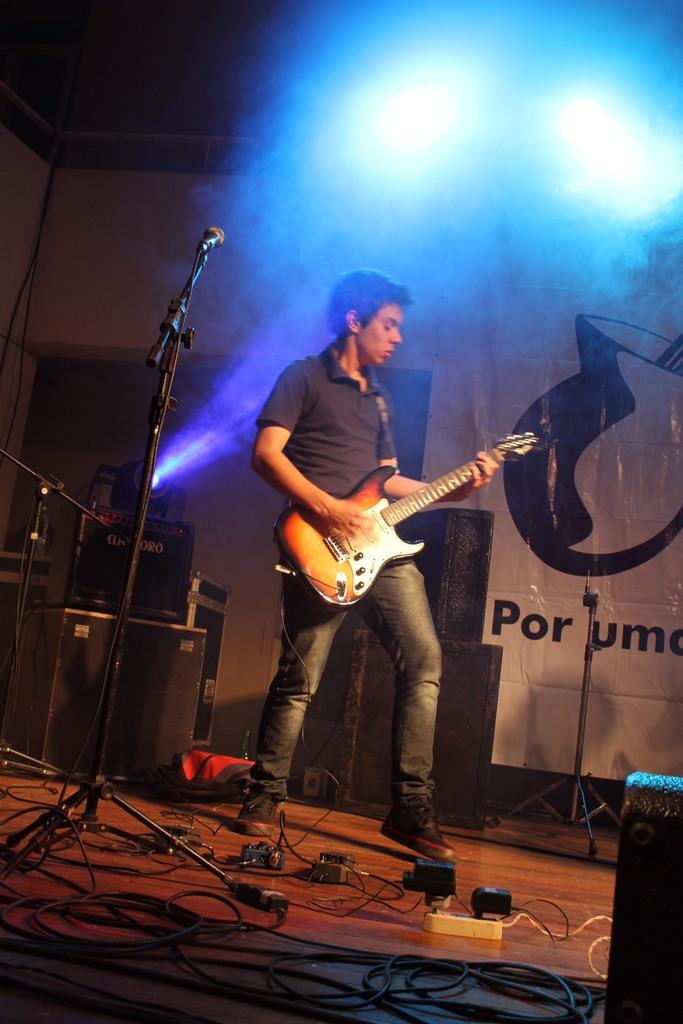Who is the main subject in the image? There is a man in the image. What is the man doing in the image? The man is playing a guitar. Where is the man located in the image? The man is on a stage. What object is present in the image that is typically used for amplifying sound? There is a microphone in the image. Can you see the man brushing his teeth with a toothbrush in the image? No, there is no toothbrush or any indication of tooth brushing in the image. Is the man laughing while playing the guitar in the image? The image does not show the man's facial expression, so it cannot be determined if he is laughing or not. 